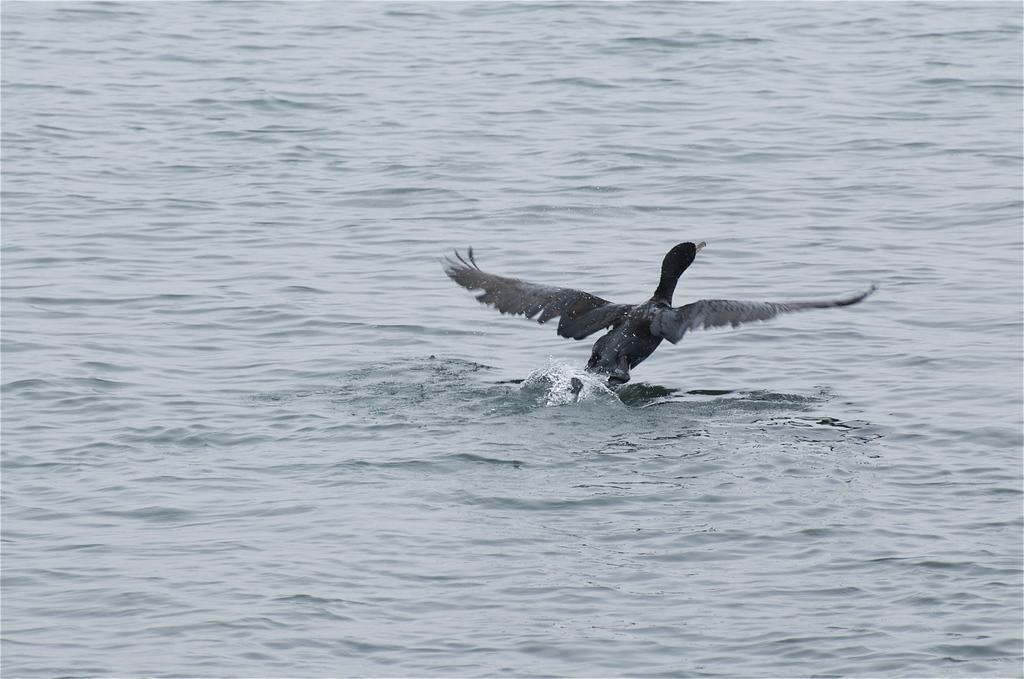Could you give a brief overview of what you see in this image? In this picture we can see the water and a bird. 